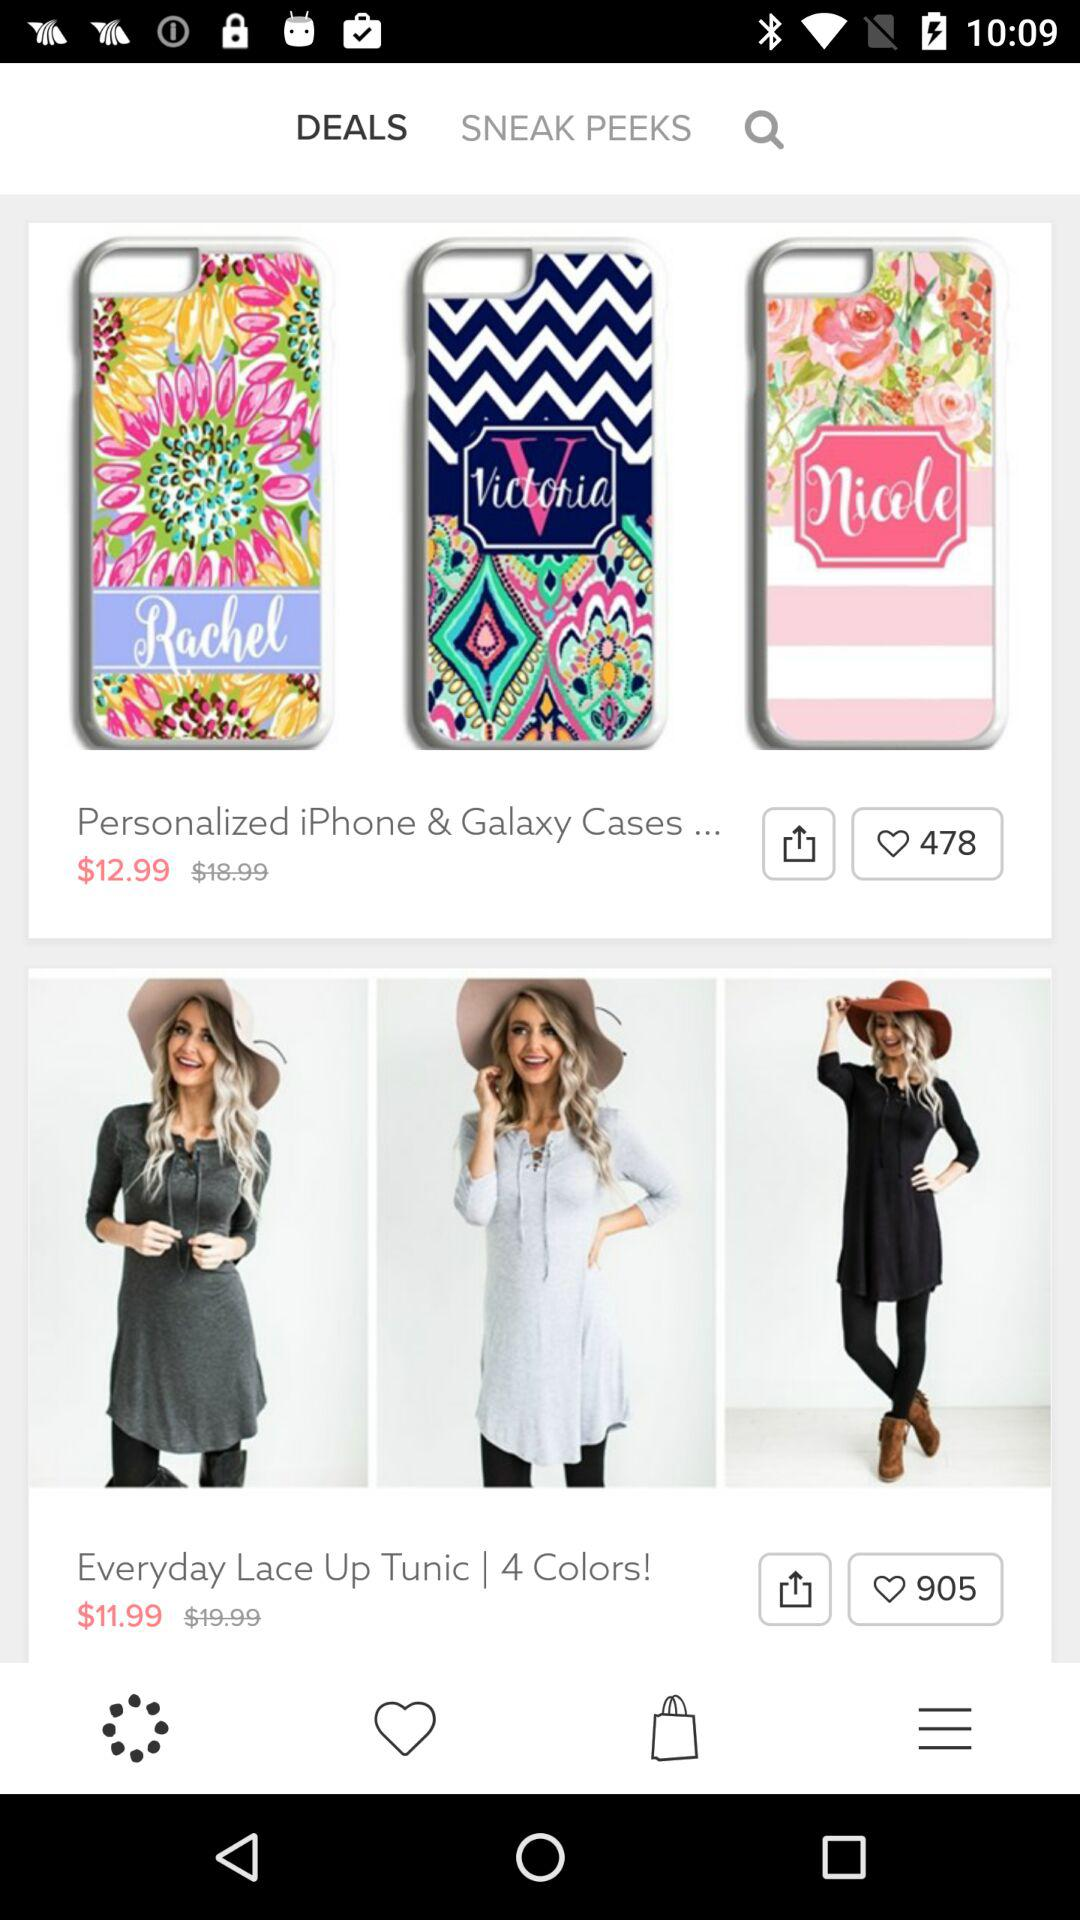How many likes in total for the "Everyday Lace Up Tunic"? The number of likes is 905. 